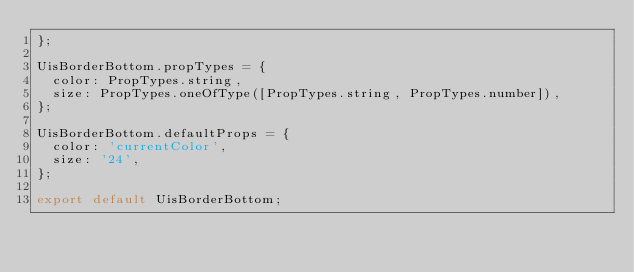Convert code to text. <code><loc_0><loc_0><loc_500><loc_500><_JavaScript_>};

UisBorderBottom.propTypes = {
  color: PropTypes.string,
  size: PropTypes.oneOfType([PropTypes.string, PropTypes.number]),
};

UisBorderBottom.defaultProps = {
  color: 'currentColor',
  size: '24',
};

export default UisBorderBottom;</code> 